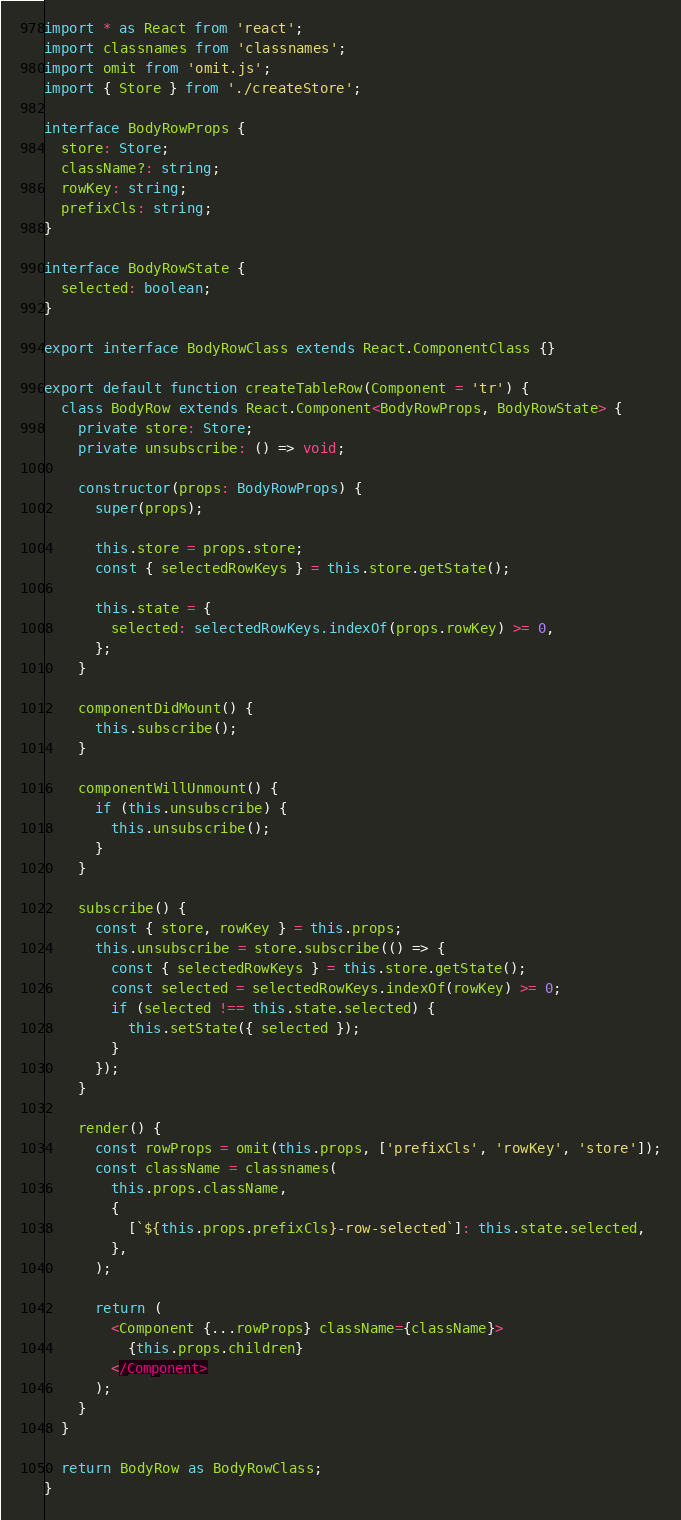<code> <loc_0><loc_0><loc_500><loc_500><_TypeScript_>import * as React from 'react';
import classnames from 'classnames';
import omit from 'omit.js';
import { Store } from './createStore';

interface BodyRowProps {
  store: Store;
  className?: string;
  rowKey: string;
  prefixCls: string;
}

interface BodyRowState {
  selected: boolean;
}

export interface BodyRowClass extends React.ComponentClass {}

export default function createTableRow(Component = 'tr') {
  class BodyRow extends React.Component<BodyRowProps, BodyRowState> {
    private store: Store;
    private unsubscribe: () => void;

    constructor(props: BodyRowProps) {
      super(props);

      this.store = props.store;
      const { selectedRowKeys } = this.store.getState();

      this.state = {
        selected: selectedRowKeys.indexOf(props.rowKey) >= 0,
      };
    }

    componentDidMount() {
      this.subscribe();
    }

    componentWillUnmount() {
      if (this.unsubscribe) {
        this.unsubscribe();
      }
    }

    subscribe() {
      const { store, rowKey } = this.props;
      this.unsubscribe = store.subscribe(() => {
        const { selectedRowKeys } = this.store.getState();
        const selected = selectedRowKeys.indexOf(rowKey) >= 0;
        if (selected !== this.state.selected) {
          this.setState({ selected });
        }
      });
    }

    render() {
      const rowProps = omit(this.props, ['prefixCls', 'rowKey', 'store']);
      const className = classnames(
        this.props.className,
        {
          [`${this.props.prefixCls}-row-selected`]: this.state.selected,
        },
      );

      return (
        <Component {...rowProps} className={className}>
          {this.props.children}
        </Component>
      );
    }
  }

  return BodyRow as BodyRowClass;
}
</code> 